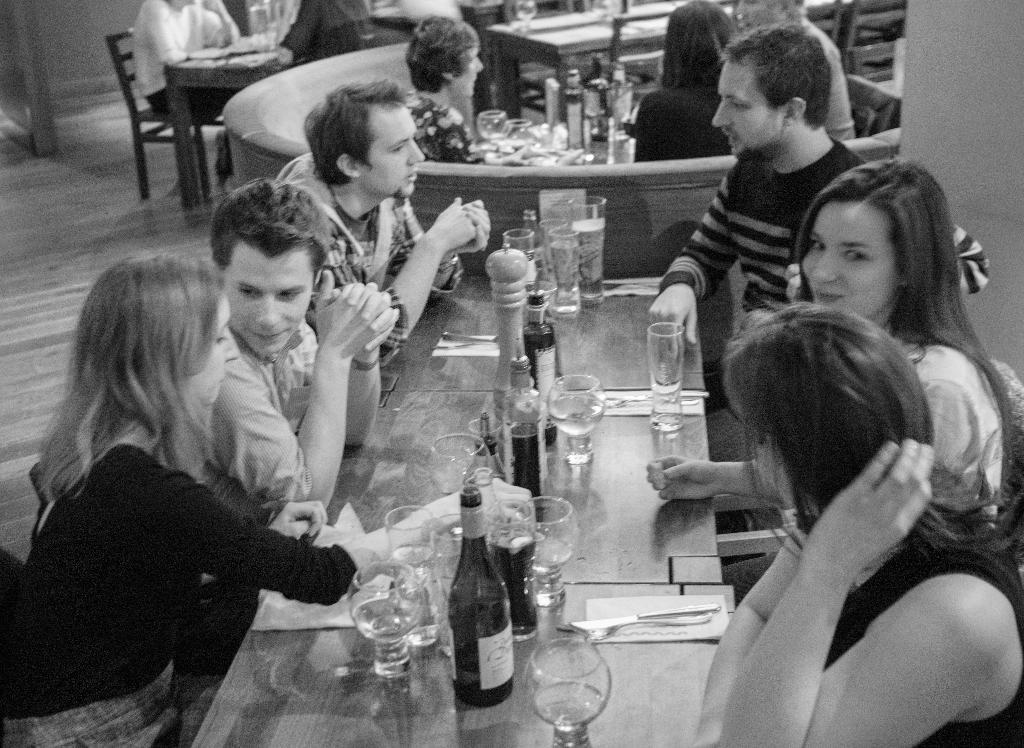What is on the table in the image? There is a glass, a bottle, and a spoon on the table. What might be used for drinking or pouring in the image? The glass and bottle on the table might be used for drinking or pouring. What is present for stirring or eating in the image? The spoon on the table can be used for stirring or eating. Who is present around the table in the image? People are sitting around the table in the image. What type of furniture is present at the table in the image? There is a chair at the table in the image. What page of the history book is open on the table in the image? There is no history book or page visible in the image; it only shows a glass, a bottle, a spoon, people sitting around the table, and a chair. 